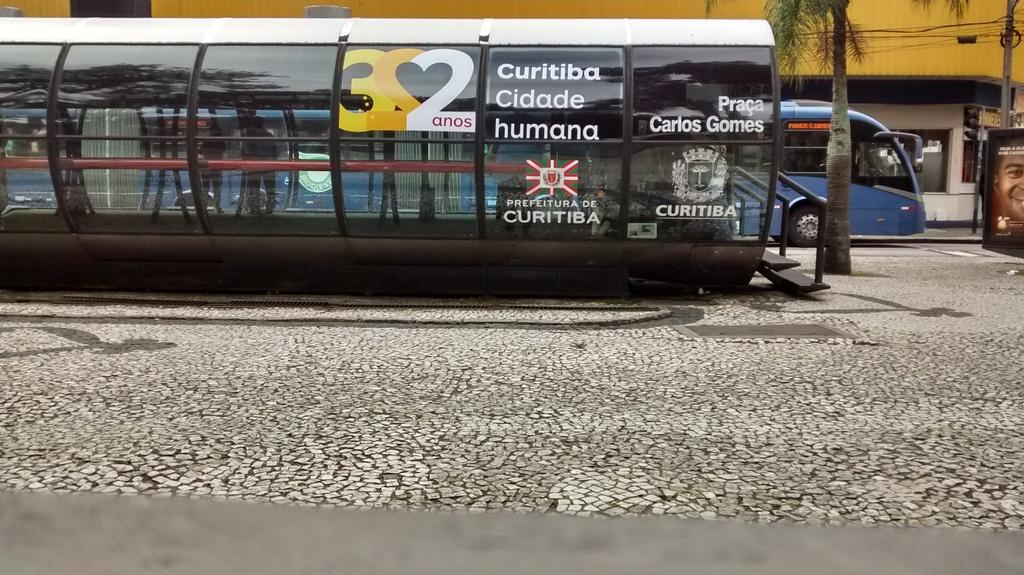Provide a one-sentence caption for the provided image. A covered bench space has a number 322 formed into a heart shaped using the mirror image of the 2s. 